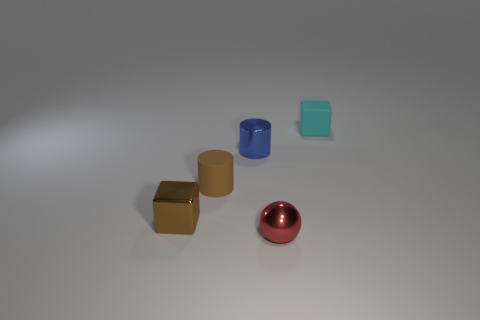Are there any small brown metal objects in front of the tiny metallic ball?
Offer a terse response. No. Do the metal thing left of the brown matte thing and the tiny rubber object left of the metallic ball have the same color?
Keep it short and to the point. Yes. Are there any metal things of the same shape as the cyan rubber object?
Make the answer very short. Yes. What number of other things are the same color as the sphere?
Your response must be concise. 0. What is the color of the metal thing that is behind the tiny cube that is on the left side of the tiny thing to the right of the tiny red metallic ball?
Make the answer very short. Blue. Is the number of cylinders in front of the tiny shiny cylinder the same as the number of brown matte cylinders?
Offer a terse response. Yes. There is a matte object to the left of the cyan block; does it have the same size as the small blue cylinder?
Provide a succinct answer. Yes. How many cylinders are there?
Your answer should be very brief. 2. How many small cubes are left of the small cyan matte thing and behind the brown rubber thing?
Ensure brevity in your answer.  0. Are there any blue cylinders made of the same material as the tiny ball?
Provide a succinct answer. Yes. 